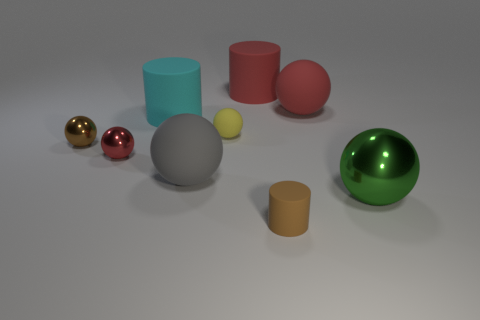Subtract all gray balls. How many balls are left? 5 Subtract 2 spheres. How many spheres are left? 4 Subtract all big rubber spheres. How many spheres are left? 4 Subtract all purple spheres. Subtract all red cylinders. How many spheres are left? 6 Add 1 cylinders. How many objects exist? 10 Subtract all balls. How many objects are left? 3 Add 5 brown metallic balls. How many brown metallic balls exist? 6 Subtract 0 purple cubes. How many objects are left? 9 Subtract all yellow rubber cubes. Subtract all small yellow objects. How many objects are left? 8 Add 9 tiny yellow objects. How many tiny yellow objects are left? 10 